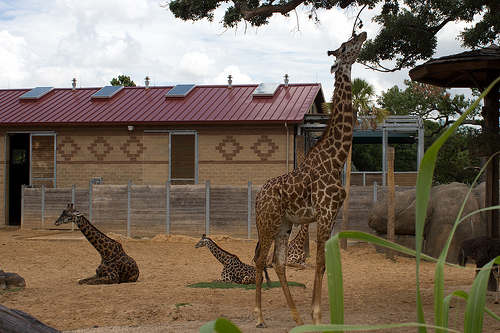Please provide a short description for this region: [0.43, 0.44, 0.59, 0.49]. The region marked by coordinates [0.43, 0.44, 0.59, 0.49] shows a diamond-shaped design on the building. 